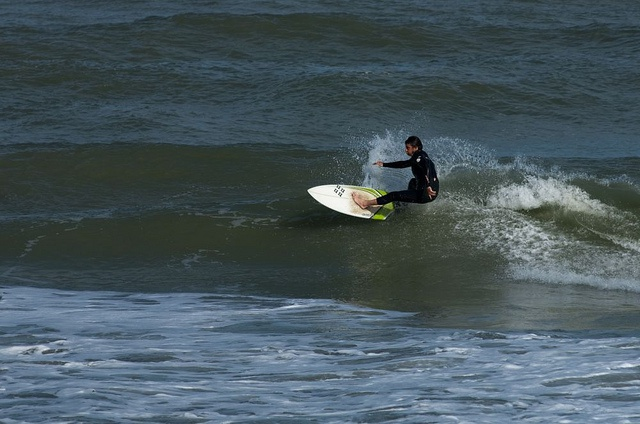Describe the objects in this image and their specific colors. I can see people in blue, black, gray, and darkgray tones and surfboard in blue, ivory, beige, darkgray, and gray tones in this image. 